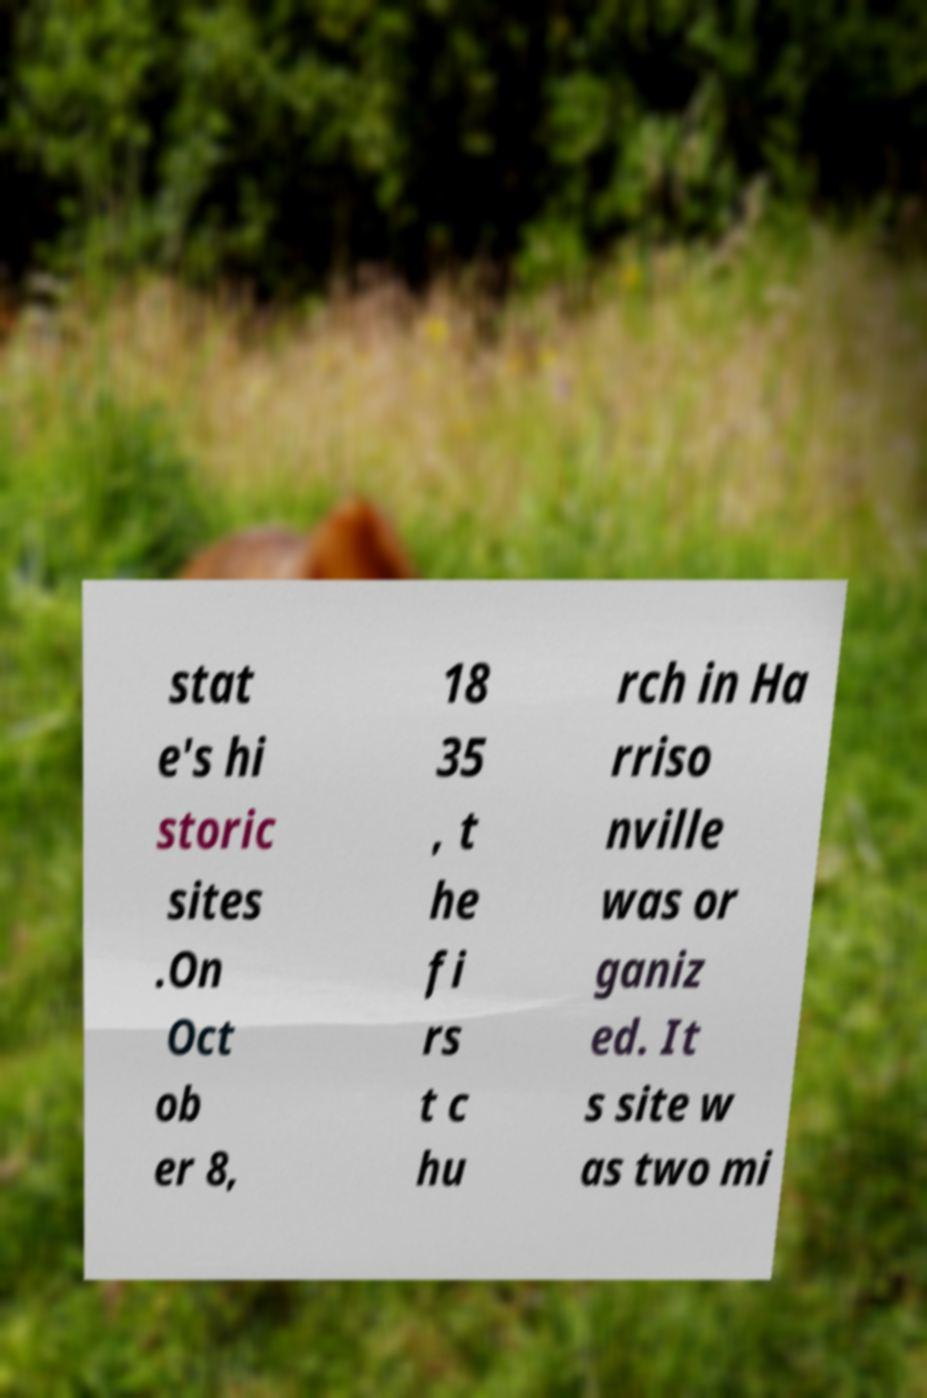Can you accurately transcribe the text from the provided image for me? stat e's hi storic sites .On Oct ob er 8, 18 35 , t he fi rs t c hu rch in Ha rriso nville was or ganiz ed. It s site w as two mi 